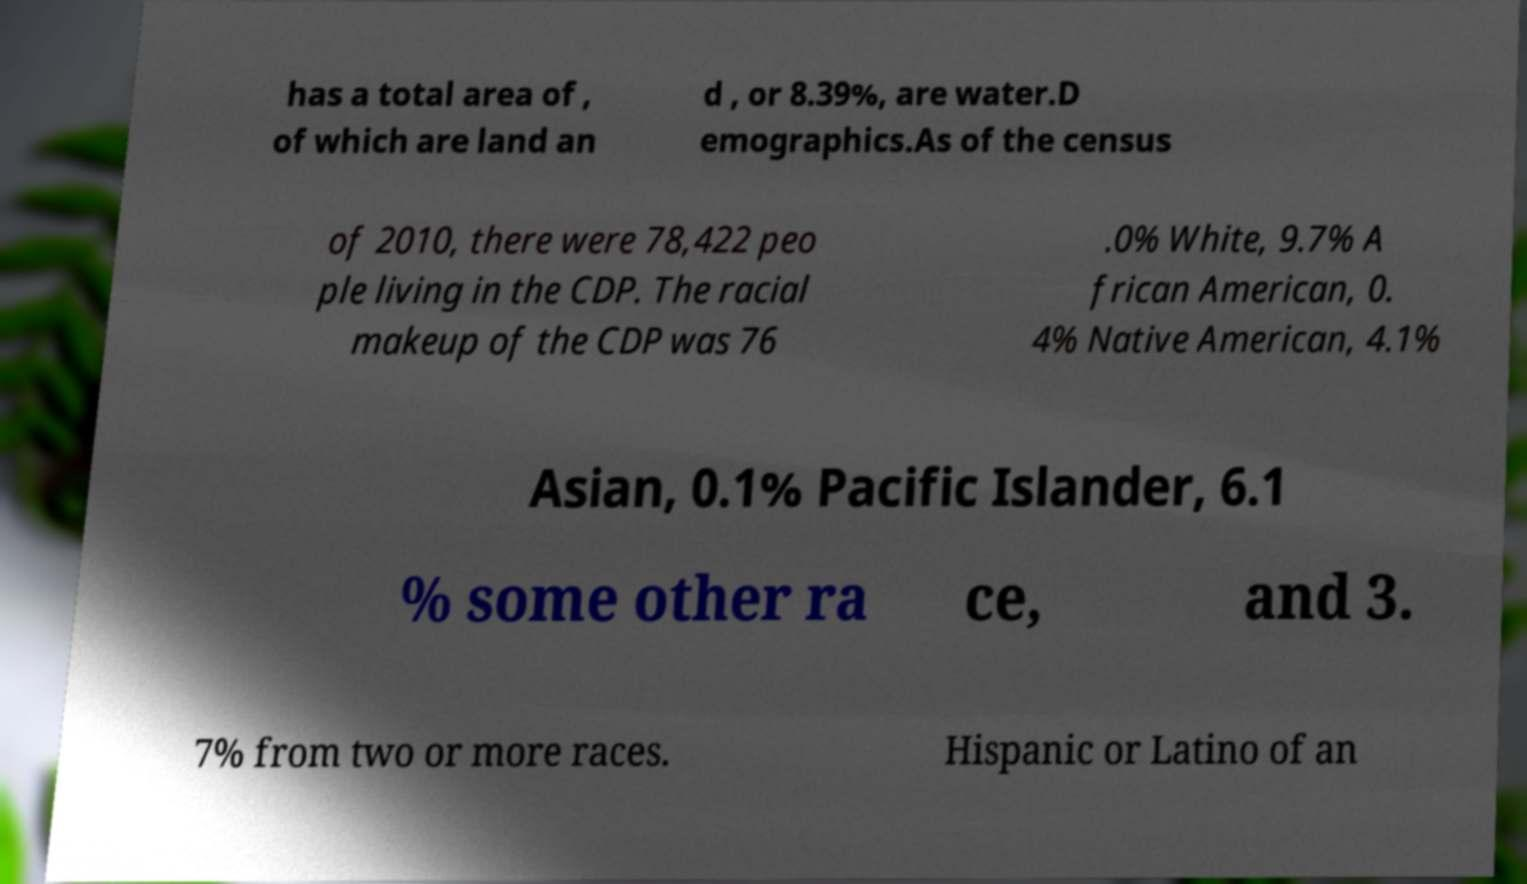I need the written content from this picture converted into text. Can you do that? has a total area of , of which are land an d , or 8.39%, are water.D emographics.As of the census of 2010, there were 78,422 peo ple living in the CDP. The racial makeup of the CDP was 76 .0% White, 9.7% A frican American, 0. 4% Native American, 4.1% Asian, 0.1% Pacific Islander, 6.1 % some other ra ce, and 3. 7% from two or more races. Hispanic or Latino of an 